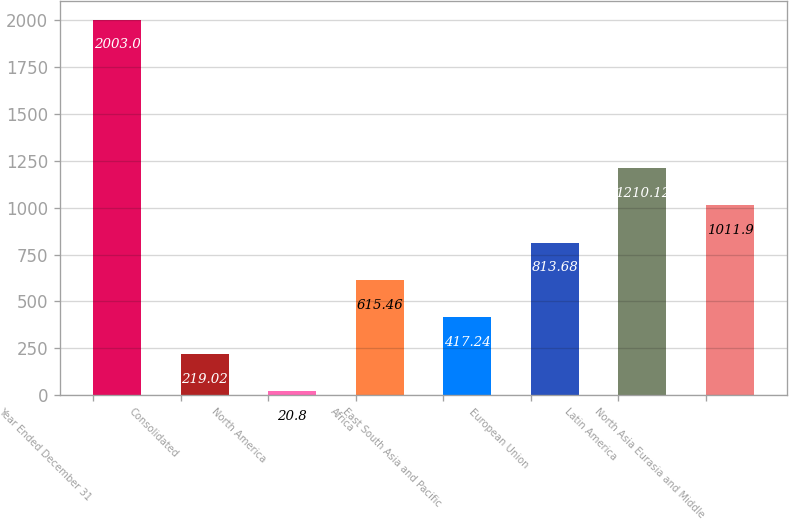Convert chart. <chart><loc_0><loc_0><loc_500><loc_500><bar_chart><fcel>Year Ended December 31<fcel>Consolidated<fcel>North America<fcel>Africa<fcel>East South Asia and Pacific<fcel>European Union<fcel>Latin America<fcel>North Asia Eurasia and Middle<nl><fcel>2003<fcel>219.02<fcel>20.8<fcel>615.46<fcel>417.24<fcel>813.68<fcel>1210.12<fcel>1011.9<nl></chart> 